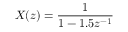Convert formula to latex. <formula><loc_0><loc_0><loc_500><loc_500>\ X ( z ) = { \frac { 1 } { 1 - 1 . 5 z ^ { - 1 } } }</formula> 